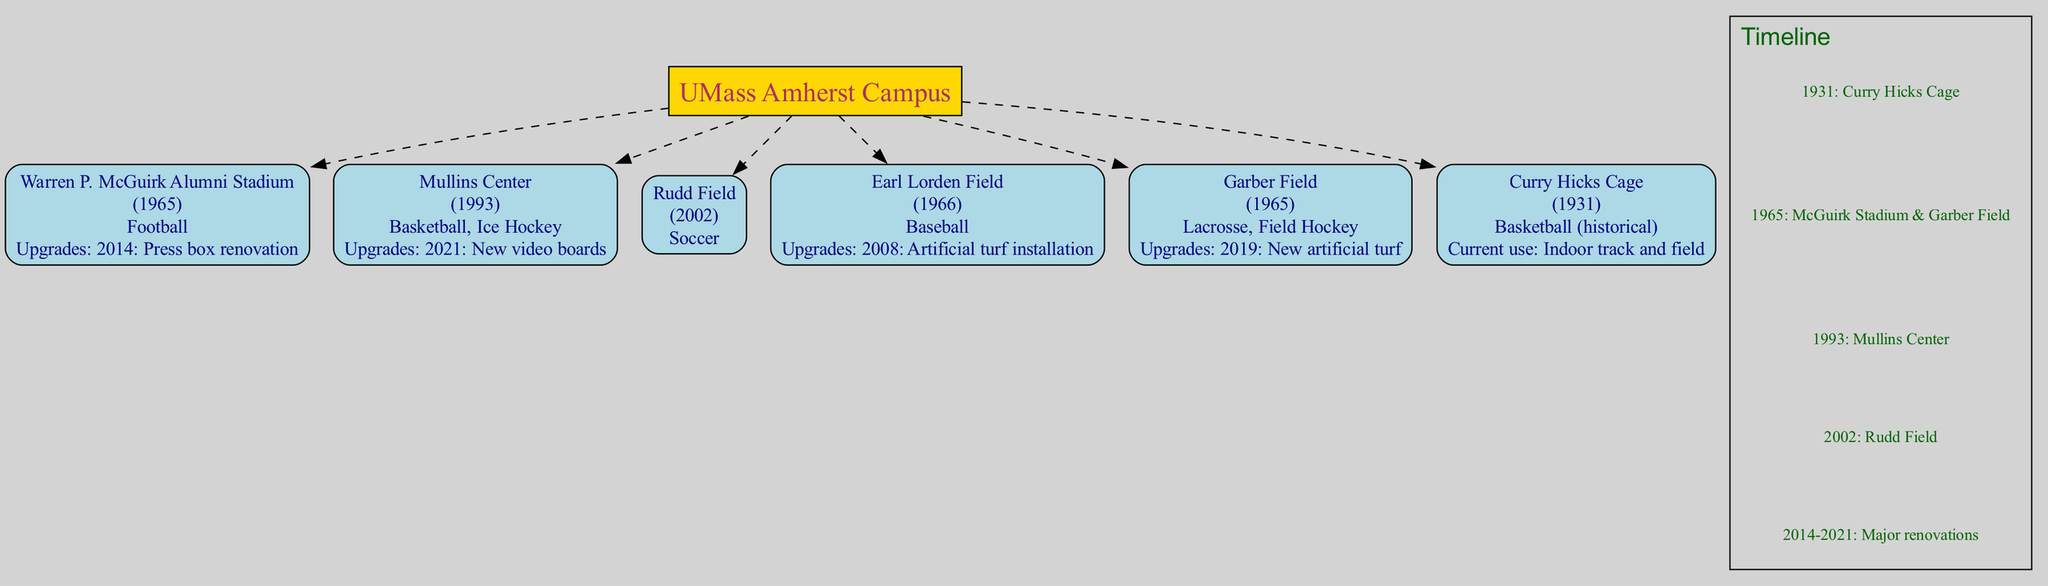What year was Warren P. McGuirk Alumni Stadium built? The diagram includes the facility's information, and it shows that Warren P. McGuirk Alumni Stadium was built in 1965.
Answer: 1965 What type of sports are played at Mullins Center? By looking at the node for Mullins Center in the diagram, it lists Basketball and Ice Hockey as the sports played there.
Answer: Basketball, Ice Hockey How many sports facilities are highlighted in the diagram? The diagram features six facilities, as counted from the nodes representing each sports facility connected to the central node.
Answer: 6 What upgrade was made to Earl Lorden Field? The node for Earl Lorden Field in the diagram lists an upgrade for 2008: Artificial turf installation, which answers the question about its upgrades.
Answer: 2008: Artificial turf installation Which facility was built first? Referring to the timeline in the diagram, the first facility listed is the Curry Hicks Cage, built in 1931, making it the earliest facility represented.
Answer: Curry Hicks Cage What major upgrade did the Mullins Center receive in 2021? The diagram specifies that the Mullins Center had new video boards installed as its upgrade in 2021.
Answer: New video boards What sport is associated with Rudd Field? The node for Rudd Field in the diagram clearly indicates that it is associated with soccer as its sport.
Answer: Soccer Which facility has a current use as "Indoor track and field"? The node describing the Curry Hicks Cage indicates that its current use has shifted to Indoor track and field, distinguishing it from its historical basketball use.
Answer: Indoor track and field What year marks the addition of Rudd Field? Among the facilities listed, Rudd Field was built in 2002, which we can verify through the diagram's details.
Answer: 2002 